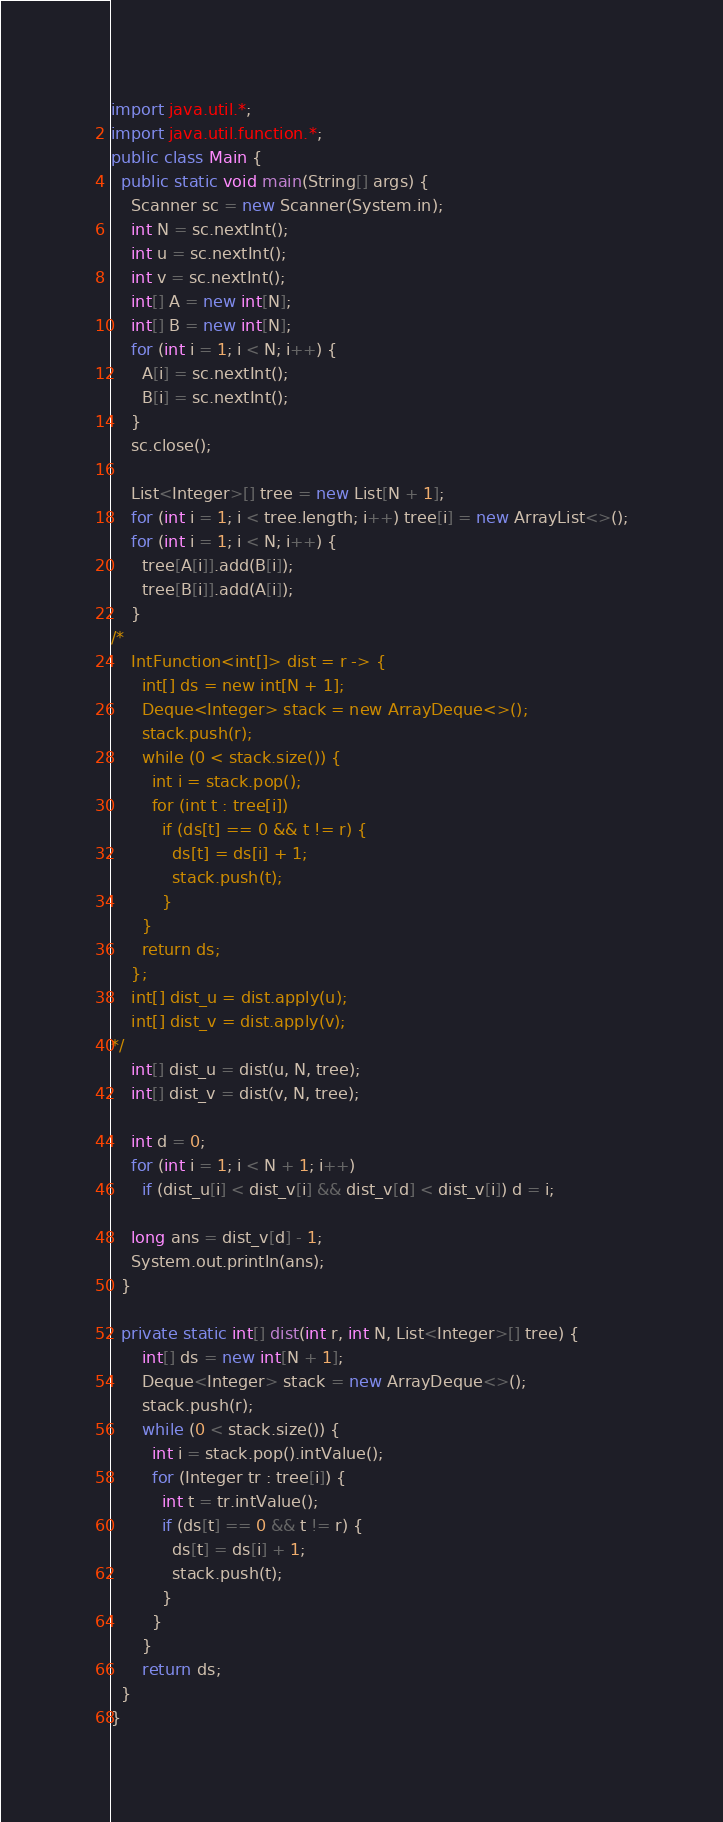Convert code to text. <code><loc_0><loc_0><loc_500><loc_500><_Java_>import java.util.*;
import java.util.function.*;
public class Main {
  public static void main(String[] args) {
    Scanner sc = new Scanner(System.in);
    int N = sc.nextInt();
    int u = sc.nextInt();
    int v = sc.nextInt();
    int[] A = new int[N];
    int[] B = new int[N];
    for (int i = 1; i < N; i++) {
      A[i] = sc.nextInt();
      B[i] = sc.nextInt();
    }
    sc.close();

    List<Integer>[] tree = new List[N + 1];
    for (int i = 1; i < tree.length; i++) tree[i] = new ArrayList<>();
    for (int i = 1; i < N; i++) {
      tree[A[i]].add(B[i]);
      tree[B[i]].add(A[i]);
    }
/*
    IntFunction<int[]> dist = r -> {
      int[] ds = new int[N + 1];
      Deque<Integer> stack = new ArrayDeque<>();
      stack.push(r);
      while (0 < stack.size()) {
        int i = stack.pop();
        for (int t : tree[i])
          if (ds[t] == 0 && t != r) {
            ds[t] = ds[i] + 1;
            stack.push(t);
          }
      }
      return ds;
    };
    int[] dist_u = dist.apply(u);
    int[] dist_v = dist.apply(v);
*/
    int[] dist_u = dist(u, N, tree);
    int[] dist_v = dist(v, N, tree);

    int d = 0;
    for (int i = 1; i < N + 1; i++)
      if (dist_u[i] < dist_v[i] && dist_v[d] < dist_v[i]) d = i;

    long ans = dist_v[d] - 1;
    System.out.println(ans);
  }
  
  private static int[] dist(int r, int N, List<Integer>[] tree) {
      int[] ds = new int[N + 1];
      Deque<Integer> stack = new ArrayDeque<>();
      stack.push(r);
      while (0 < stack.size()) {
        int i = stack.pop().intValue();
        for (Integer tr : tree[i]) {
          int t = tr.intValue();
          if (ds[t] == 0 && t != r) {
            ds[t] = ds[i] + 1;
            stack.push(t);
          }
        }
      }
      return ds;
  }
}</code> 